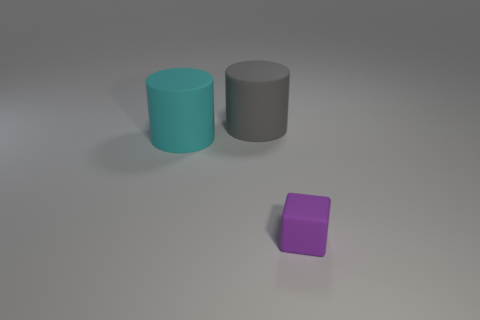Is there anything else that is the same size as the purple cube?
Offer a very short reply. No. Does the large thing that is in front of the gray cylinder have the same material as the large cylinder behind the cyan cylinder?
Give a very brief answer. Yes. How many things are objects that are to the left of the tiny purple object or matte objects that are to the left of the rubber cube?
Provide a succinct answer. 2. How big is the matte cylinder in front of the object behind the cyan rubber thing?
Your response must be concise. Large. The gray rubber cylinder has what size?
Offer a very short reply. Large. Are any red matte objects visible?
Provide a short and direct response. No. There is another thing that is the same shape as the big cyan thing; what is its material?
Ensure brevity in your answer.  Rubber. Are there fewer gray things than large brown spheres?
Offer a very short reply. No. Does the large object that is in front of the gray cylinder have the same color as the matte cube?
Provide a short and direct response. No. What is the color of the block that is made of the same material as the large gray thing?
Your response must be concise. Purple. 